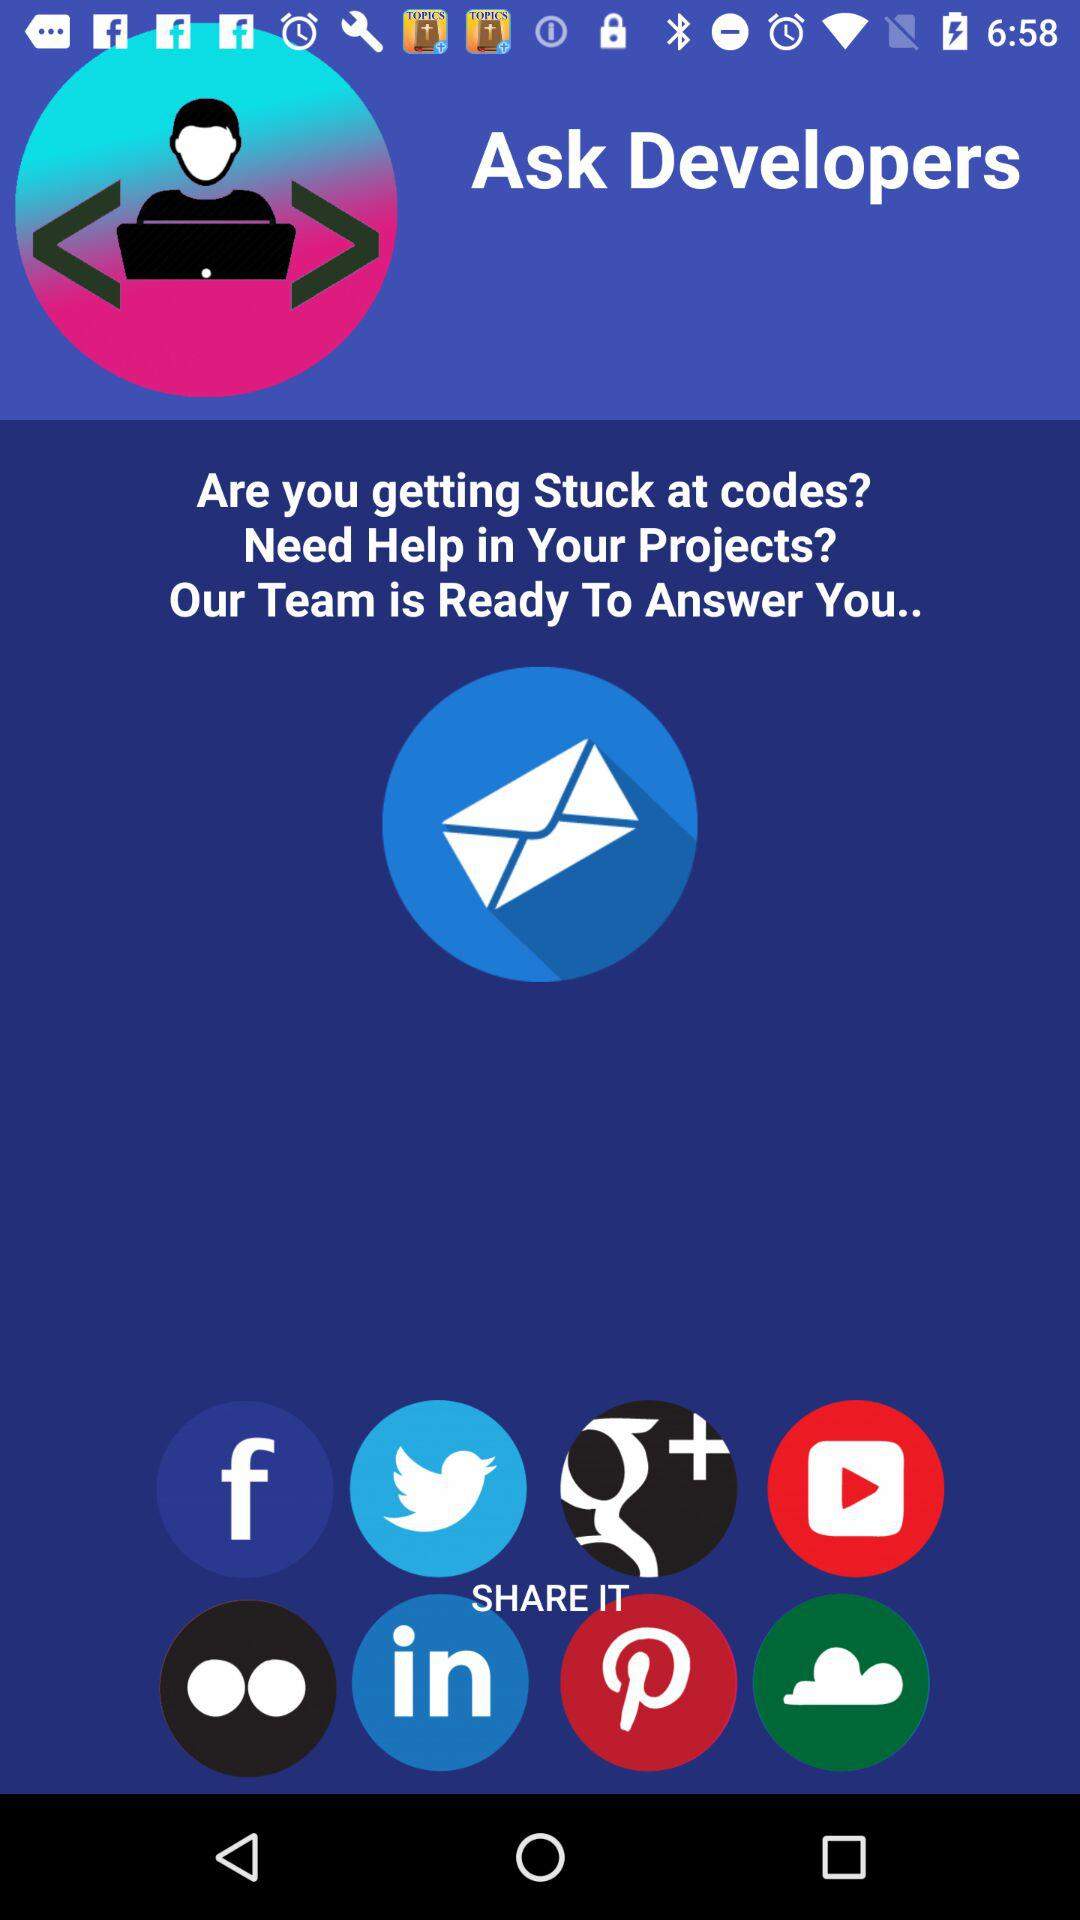How many team members are ready to answer us?
When the provided information is insufficient, respond with <no answer>. <no answer> 